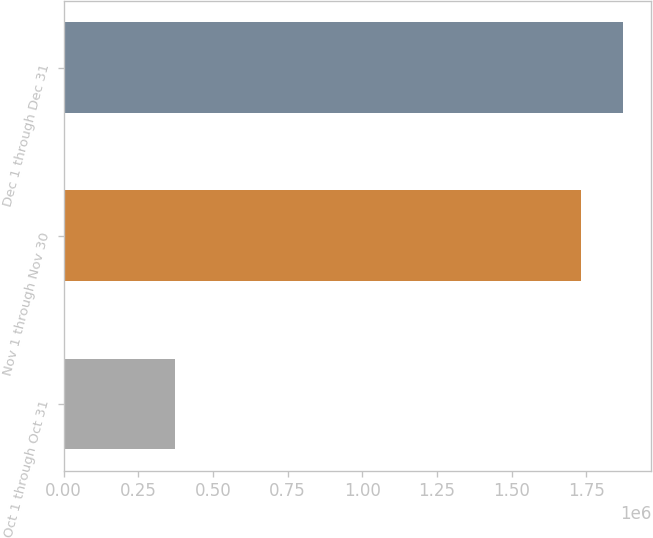Convert chart. <chart><loc_0><loc_0><loc_500><loc_500><bar_chart><fcel>Oct 1 through Oct 31<fcel>Nov 1 through Nov 30<fcel>Dec 1 through Dec 31<nl><fcel>371639<fcel>1.73388e+06<fcel>1.87473e+06<nl></chart> 